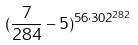<formula> <loc_0><loc_0><loc_500><loc_500>( \frac { 7 } { 2 8 4 } - 5 ) ^ { 5 6 \cdot 3 0 2 ^ { 2 8 2 } }</formula> 